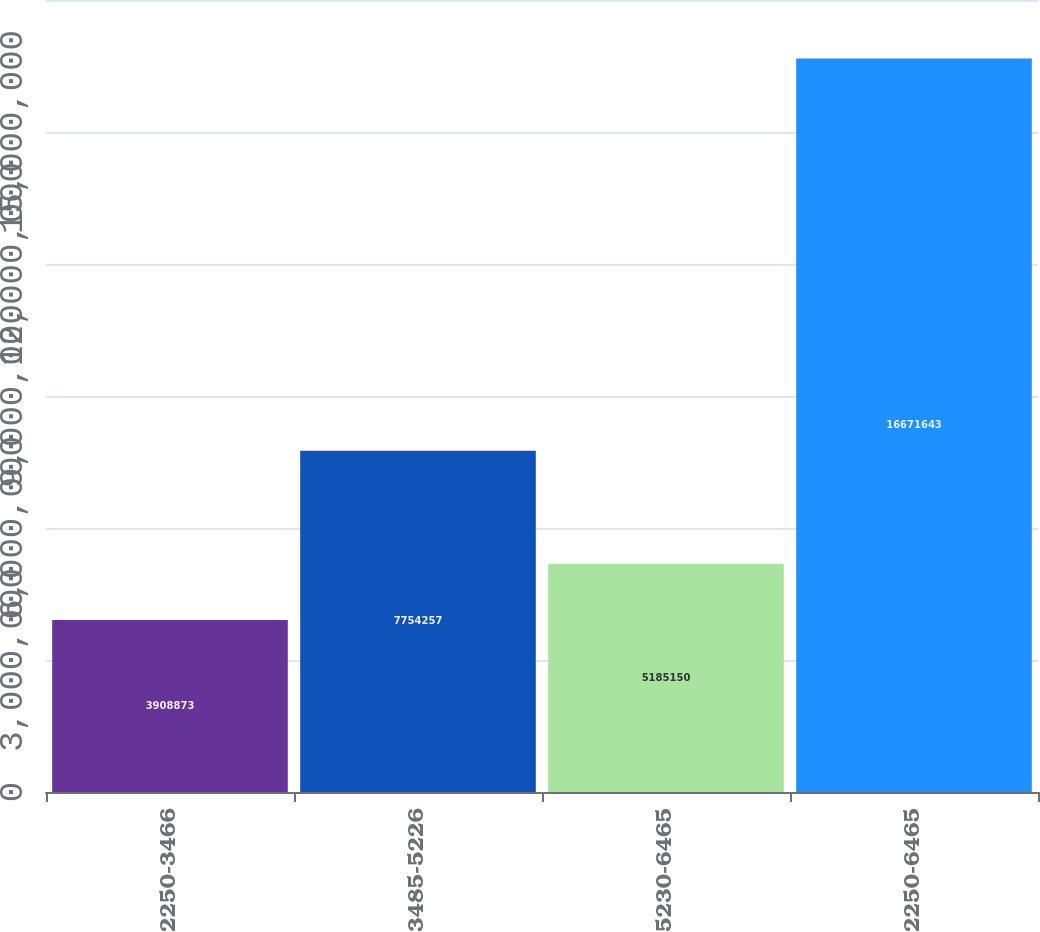<chart> <loc_0><loc_0><loc_500><loc_500><bar_chart><fcel>2250-3466<fcel>3485-5226<fcel>5230-6465<fcel>2250-6465<nl><fcel>3.90887e+06<fcel>7.75426e+06<fcel>5.18515e+06<fcel>1.66716e+07<nl></chart> 